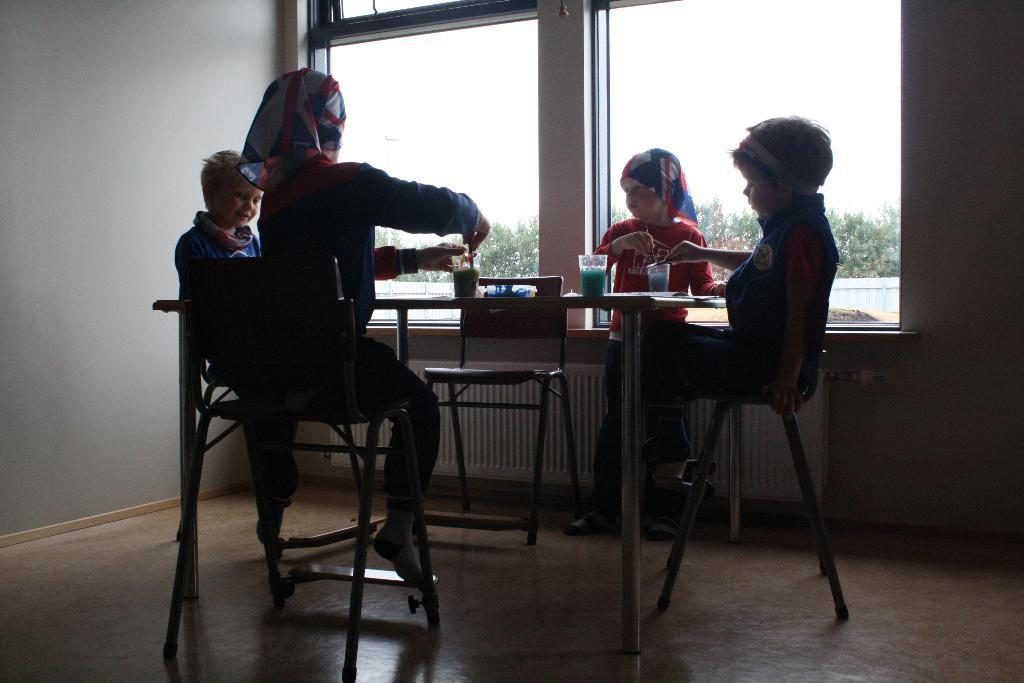How many boys are present in the image? There are four boys in the image. What are the positions of the boys in the image? Three of the boys are sitting in chairs, and one is standing. Where are the boys located in relation to each other? All the boys are around a table. What type of loaf can be seen on the table in the image? There is no loaf present on the table in the image. How does the dust affect the boys' activities in the image? There is no mention of dust in the image, so it cannot be determined how it might affect the boys' activities. 